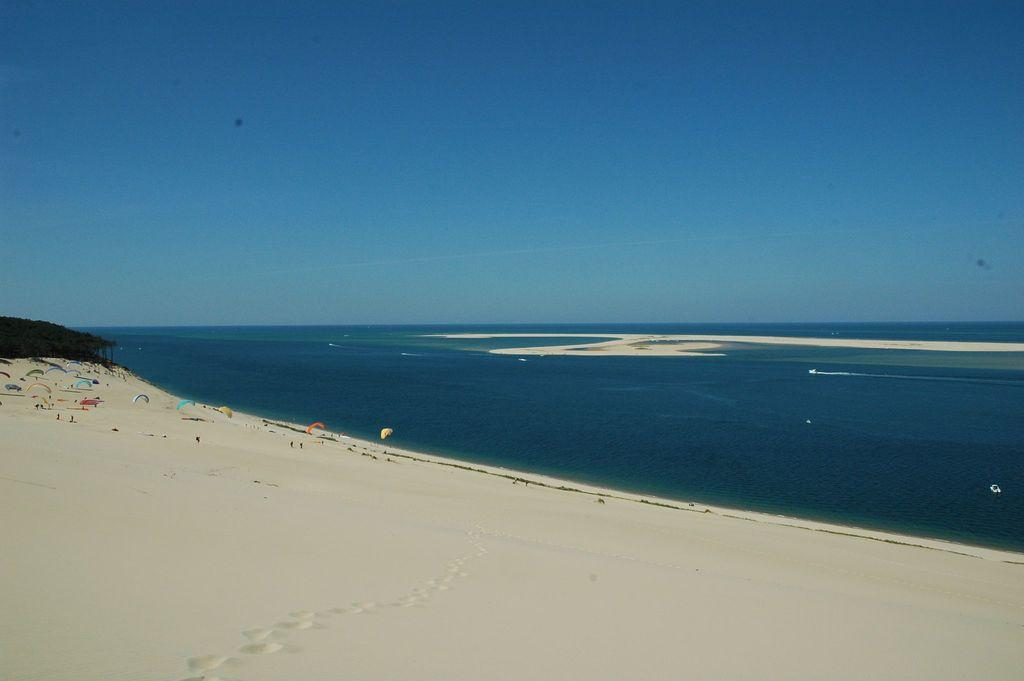Where was the image taken? The image was taken at a beach. What can be seen in the middle of the image? There is water in the middle of the image. What is located on the left side of the image? There are parachutes on the left side of the image. What is visible at the top of the image? The sky is visible at the top of the image. What type of cave can be seen in the background of the image? There is no cave present in the image; it was taken at a beach with water, parachutes, and a visible sky. 